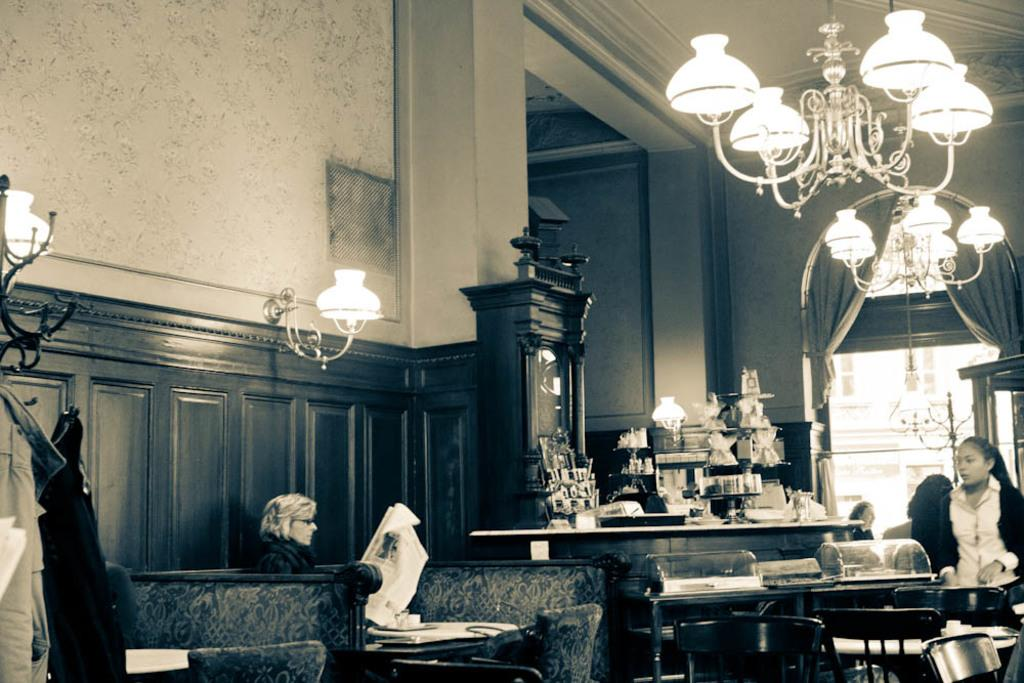What type of lighting fixture is present in the image? There is a chandelier light in the image. How many women are seated in the image? There are two women seated on chairs in the image. What type of furniture is visible in the image? There are tables visible in the image. Is there a dock visible in the image? No, there is no dock present in the image. What type of weather condition is depicted in the image? The provided facts do not mention any weather conditions, so it cannot be determined from the image. 